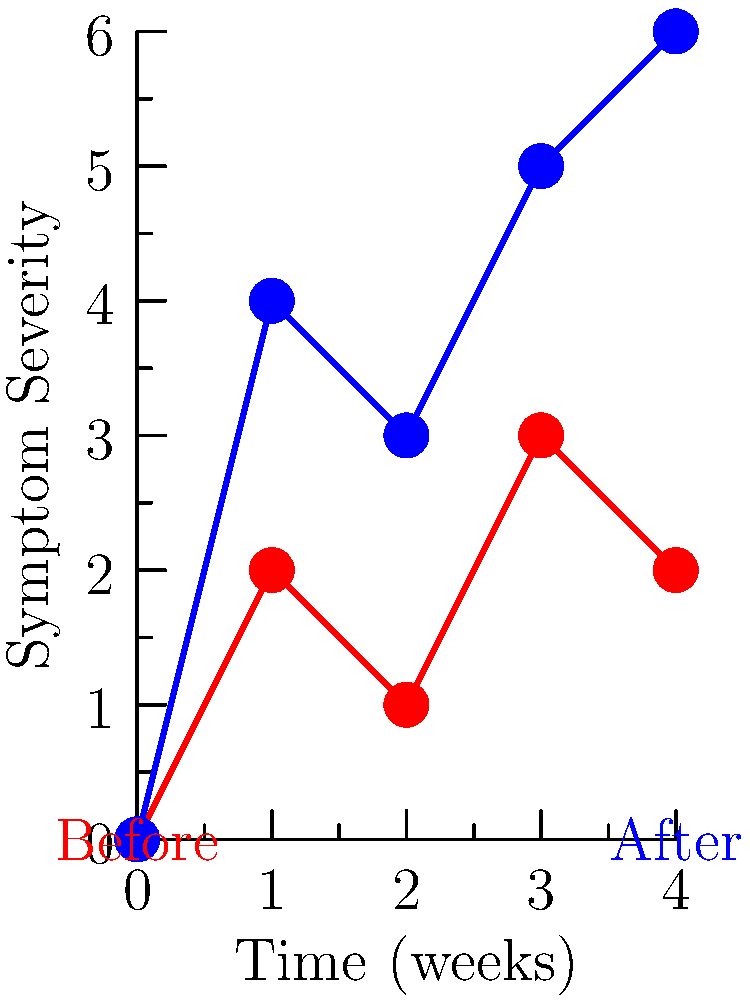As a psychiatrist supervising a resident, you're reviewing before-and-after photographs of a patient who started a new antipsychotic medication 4 weeks ago. The resident has plotted the patient's symptom severity over time, as shown in the graph. What potential side effect of the medication should you discuss with the resident based on this data? To identify the potential side effect, we need to analyze the graph:

1. Observe the two lines: red (before treatment) and blue (after treatment).
2. Note that the y-axis represents "Symptom Severity" and the x-axis represents "Time (weeks)".
3. The blue line (after treatment) shows a consistent upward trend compared to the red line (before treatment).
4. In psychiatry, an increase in symptom severity after starting a new medication could indicate various issues, but one common concern is akathisia.
5. Akathisia is a movement disorder characterized by a feeling of inner restlessness and a compelling need to be in constant motion. It's a common side effect of antipsychotic medications.
6. The increasing symptom severity over time aligns with the typical presentation of akathisia, which often develops within the first few weeks of starting or increasing the dose of an antipsychotic.
7. As a seasoned psychiatrist, it's crucial to recognize this pattern early to adjust treatment and prevent potential non-compliance due to discomfort.

Therefore, based on the increasing trend of symptom severity after starting the new medication, akathisia should be discussed as a potential side effect.
Answer: Akathisia 